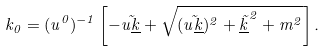Convert formula to latex. <formula><loc_0><loc_0><loc_500><loc_500>k _ { 0 } = ( u ^ { 0 } ) ^ { - 1 } \left [ - \vec { u \underline { k } } + \sqrt { ( \vec { u \underline { k } } ) ^ { 2 } + \vec { \underline { k } } ^ { 2 } + m ^ { 2 } } \right ] .</formula> 